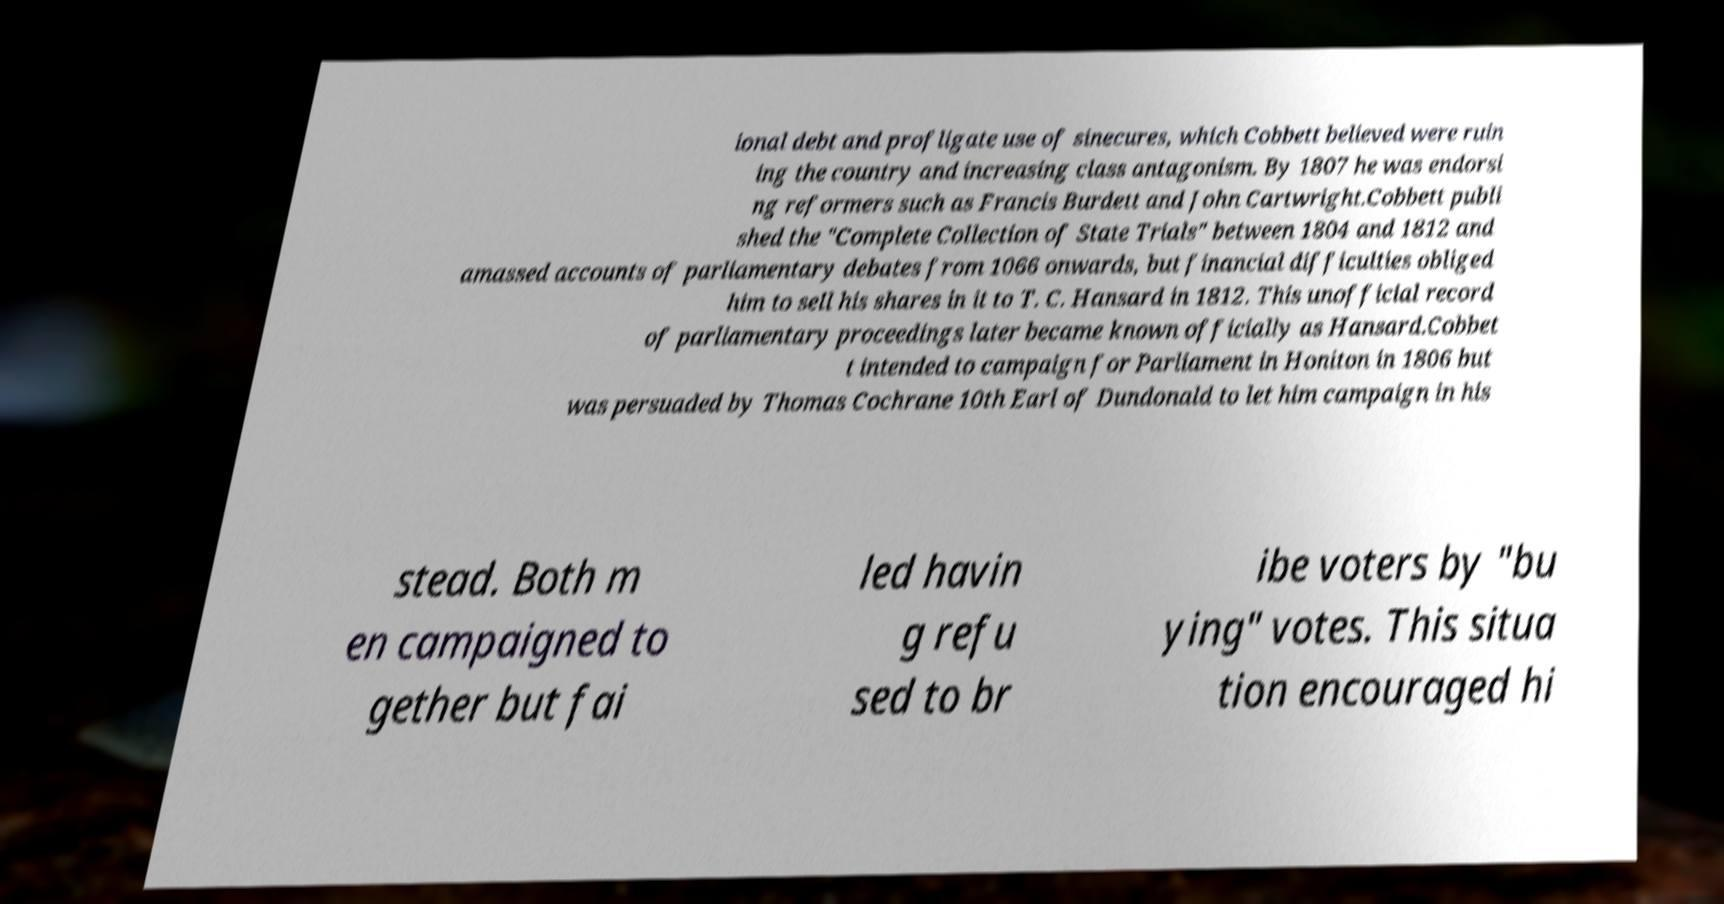I need the written content from this picture converted into text. Can you do that? ional debt and profligate use of sinecures, which Cobbett believed were ruin ing the country and increasing class antagonism. By 1807 he was endorsi ng reformers such as Francis Burdett and John Cartwright.Cobbett publi shed the "Complete Collection of State Trials" between 1804 and 1812 and amassed accounts of parliamentary debates from 1066 onwards, but financial difficulties obliged him to sell his shares in it to T. C. Hansard in 1812. This unofficial record of parliamentary proceedings later became known officially as Hansard.Cobbet t intended to campaign for Parliament in Honiton in 1806 but was persuaded by Thomas Cochrane 10th Earl of Dundonald to let him campaign in his stead. Both m en campaigned to gether but fai led havin g refu sed to br ibe voters by "bu ying" votes. This situa tion encouraged hi 